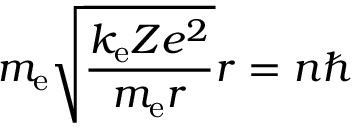<formula> <loc_0><loc_0><loc_500><loc_500>m _ { e } { \sqrt { \frac { k _ { e } Z e ^ { 2 } } { m _ { e } r } } } r = n \hbar</formula> 